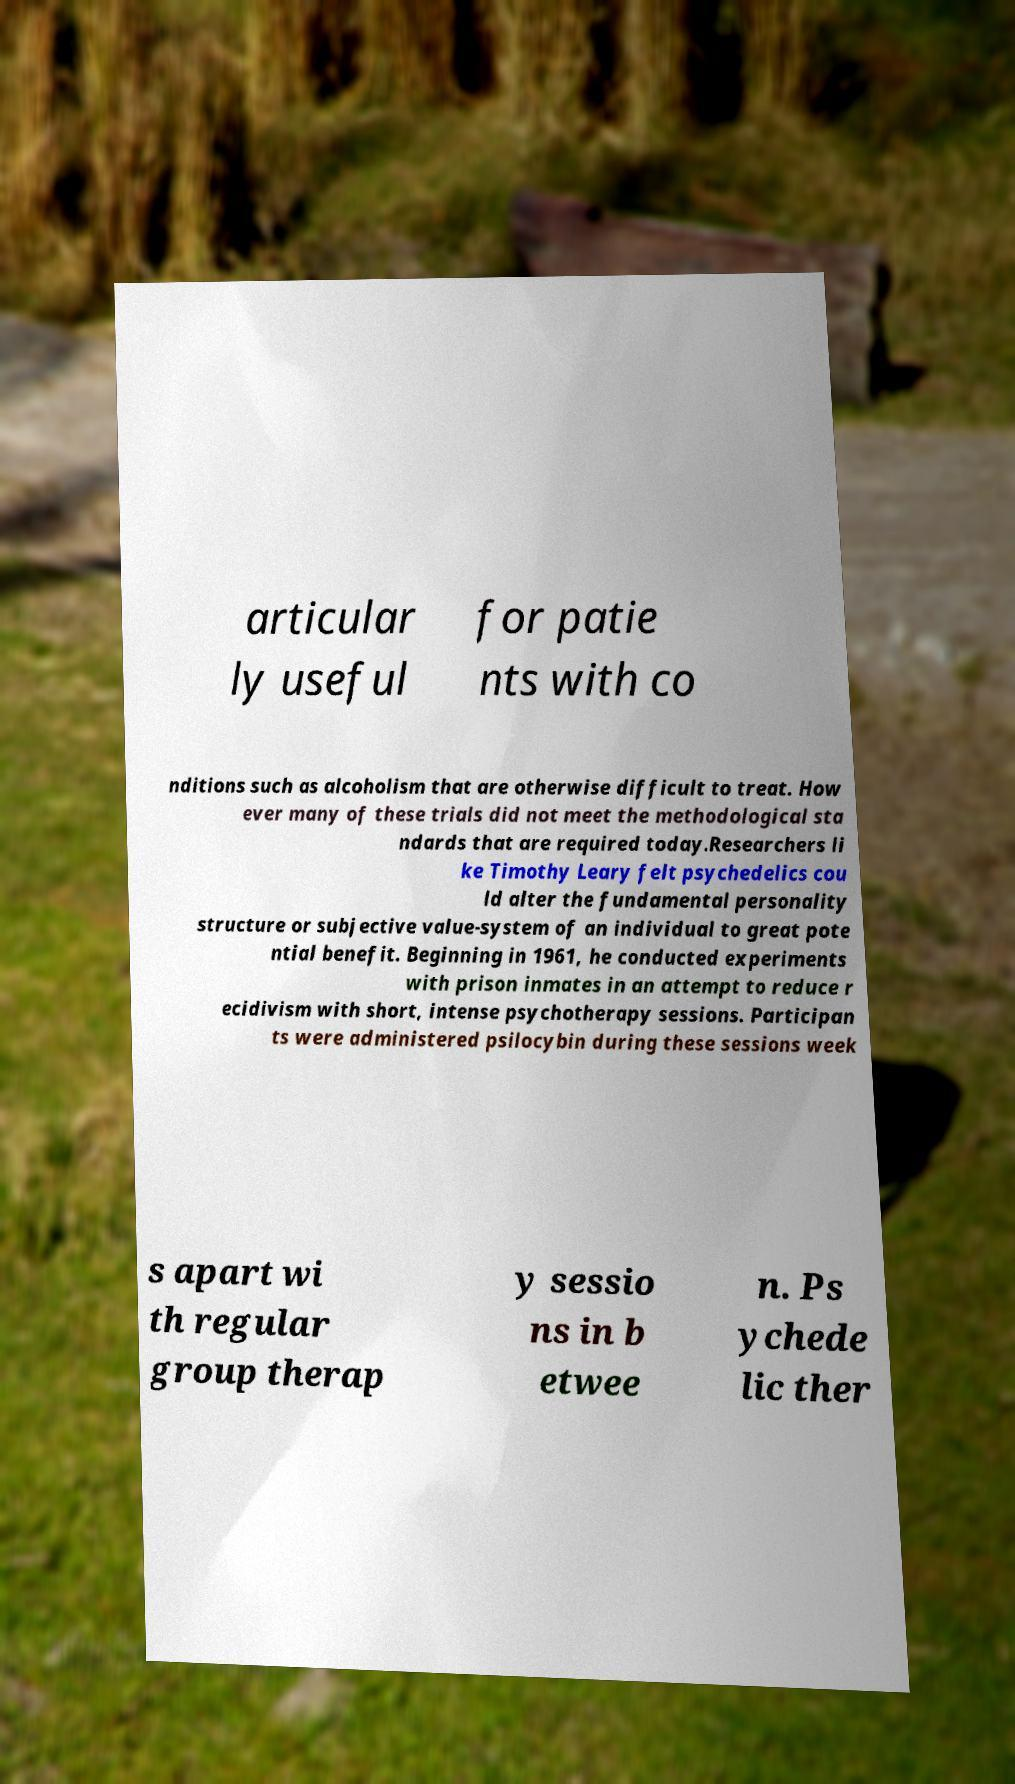I need the written content from this picture converted into text. Can you do that? articular ly useful for patie nts with co nditions such as alcoholism that are otherwise difficult to treat. How ever many of these trials did not meet the methodological sta ndards that are required today.Researchers li ke Timothy Leary felt psychedelics cou ld alter the fundamental personality structure or subjective value-system of an individual to great pote ntial benefit. Beginning in 1961, he conducted experiments with prison inmates in an attempt to reduce r ecidivism with short, intense psychotherapy sessions. Participan ts were administered psilocybin during these sessions week s apart wi th regular group therap y sessio ns in b etwee n. Ps ychede lic ther 